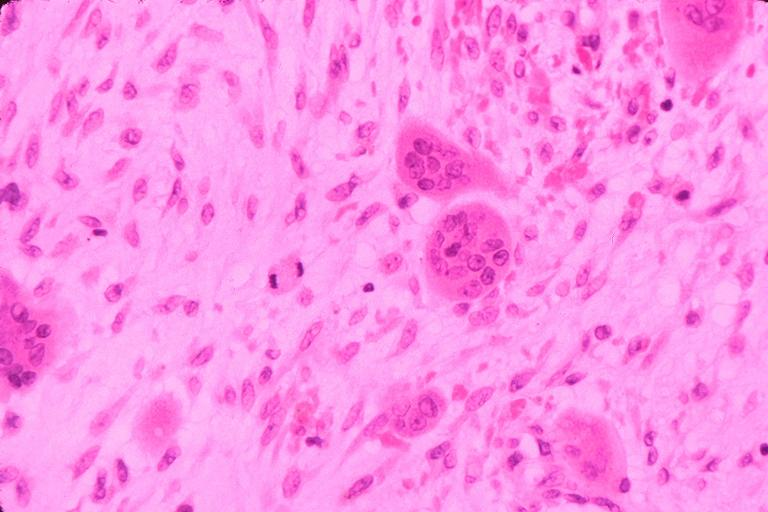does this image show cherubism?
Answer the question using a single word or phrase. Yes 